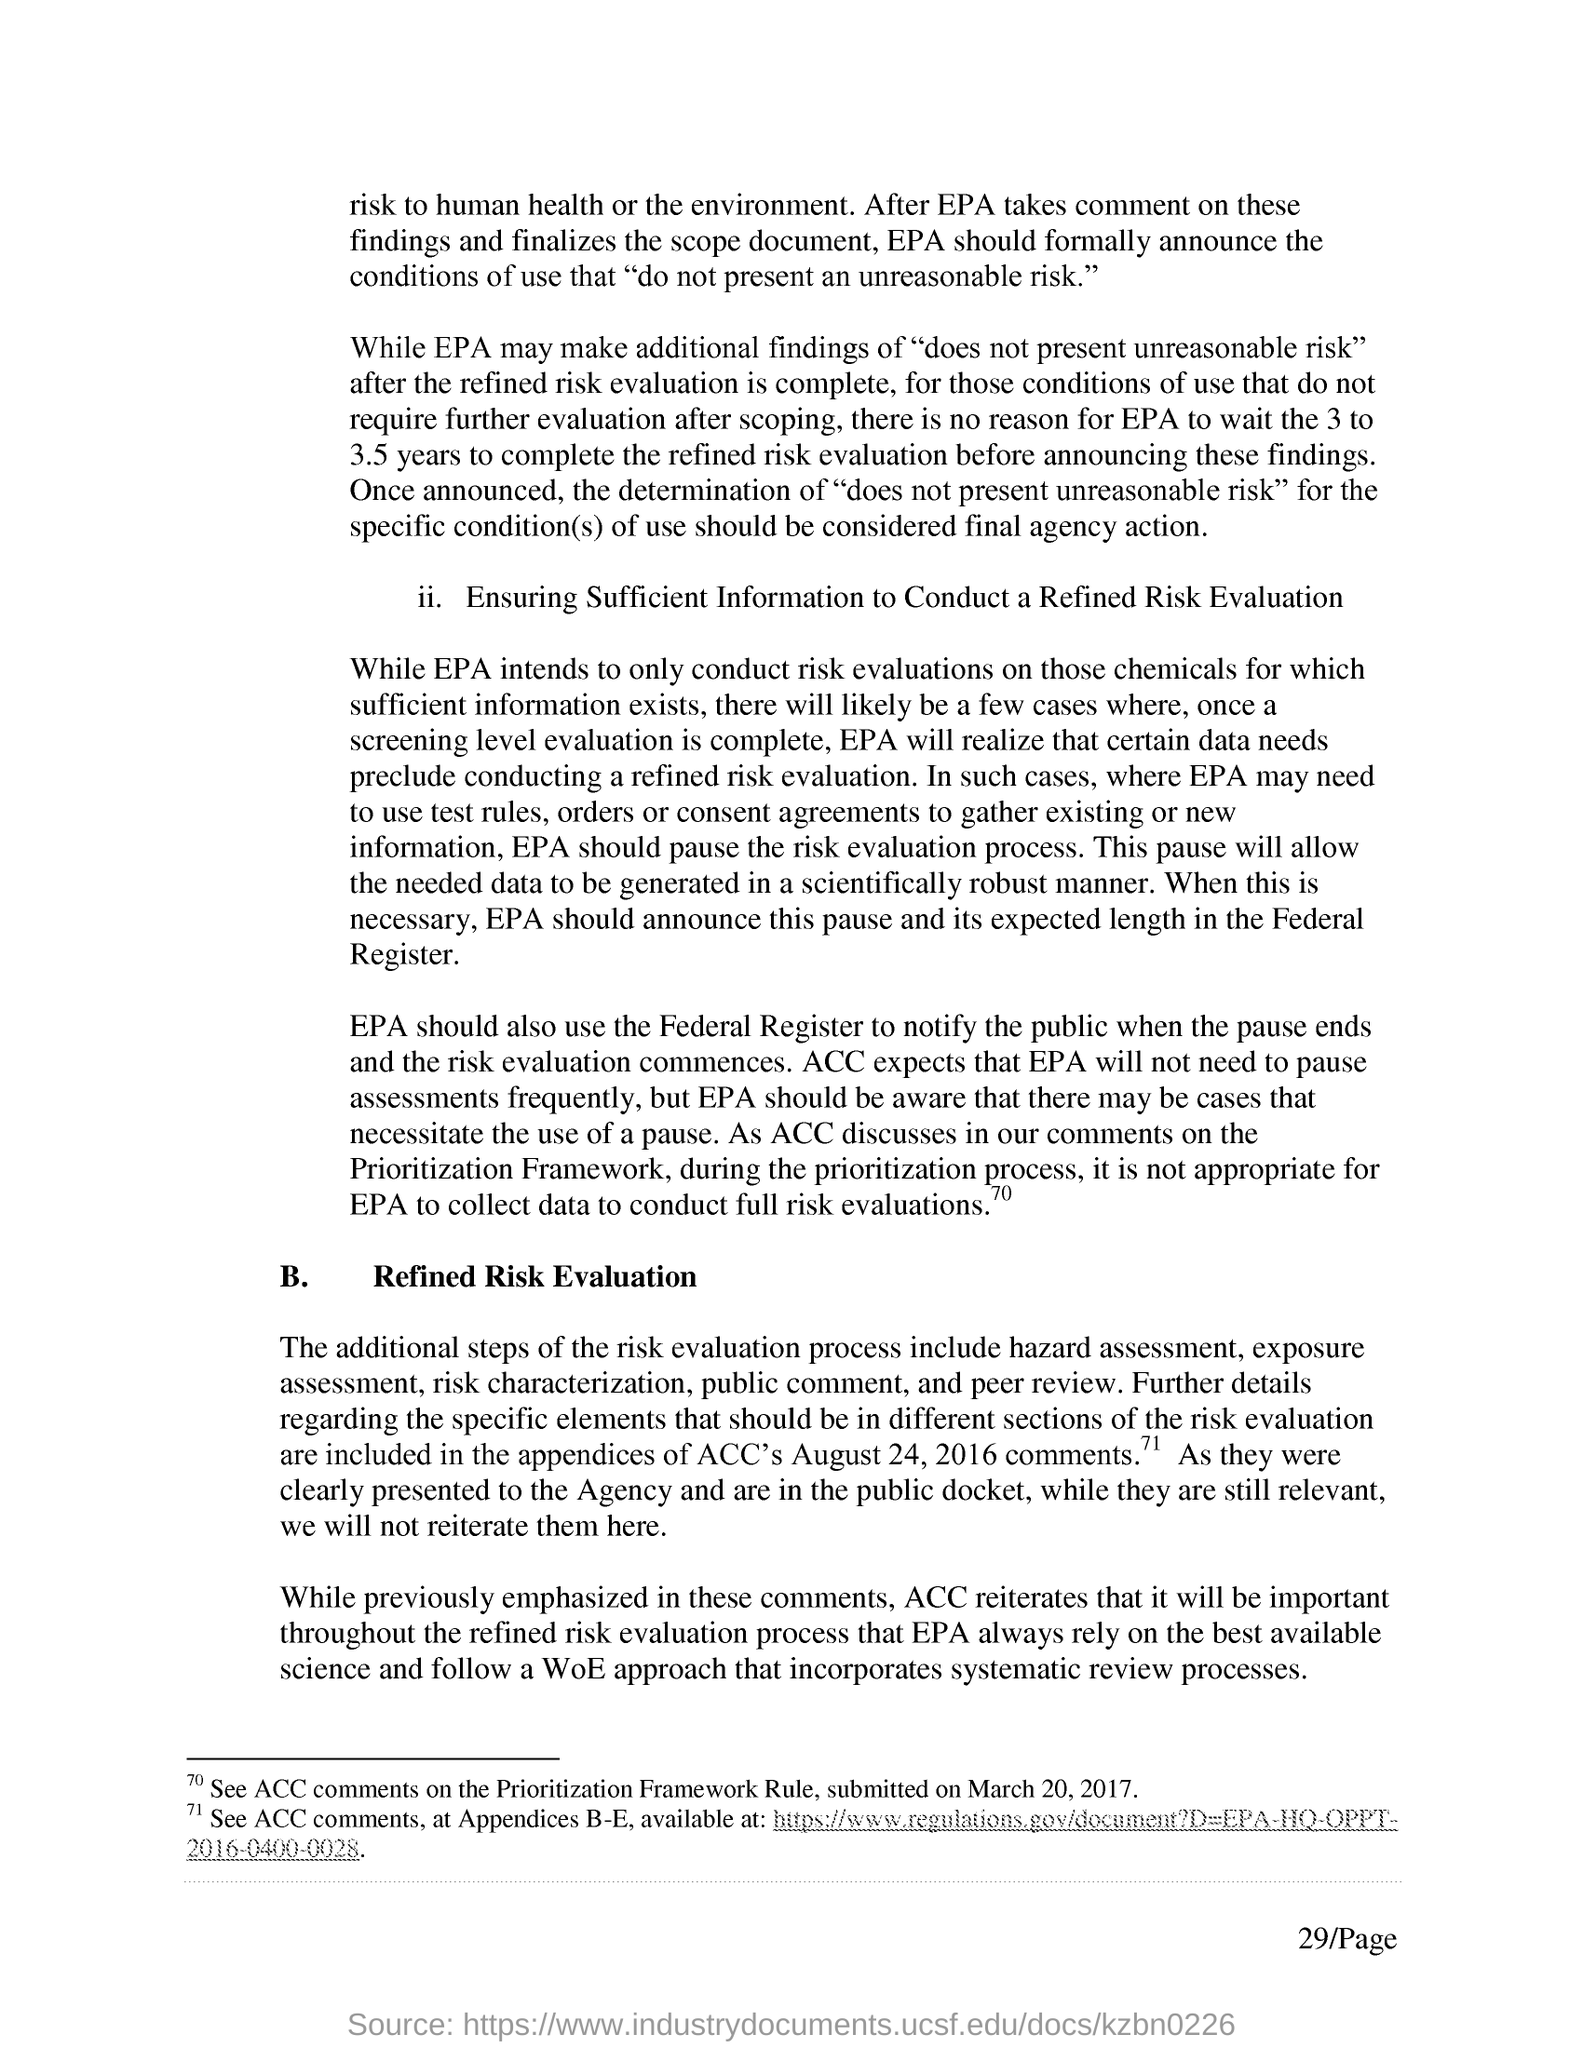What are the additional steps of the risk evaluation process?
Your answer should be compact. Hazard assessment, exposure assessment, risk characterization, public comment, and peer review. What is the page no mentioned in this document?
Offer a terse response. 29/Page. When was the ACC comments on the prioritization Framework Rule submitted?
Your answer should be compact. Submitted on march 20, 2017. 